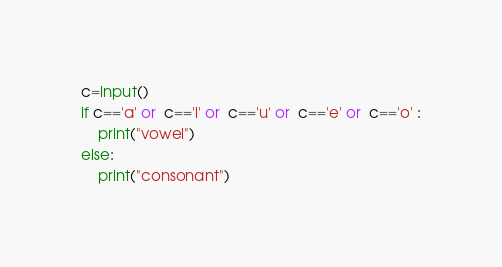<code> <loc_0><loc_0><loc_500><loc_500><_Python_>c=input()
if c=='a' or  c=='i' or  c=='u' or  c=='e' or  c=='o' :
    print("vowel")
else:
    print("consonant")
</code> 